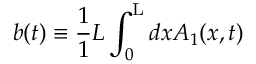<formula> <loc_0><loc_0><loc_500><loc_500>b ( t ) \equiv \frac { 1 } { 1 } { L } \int _ { 0 } ^ { L } d x A _ { 1 } ( x , t )</formula> 